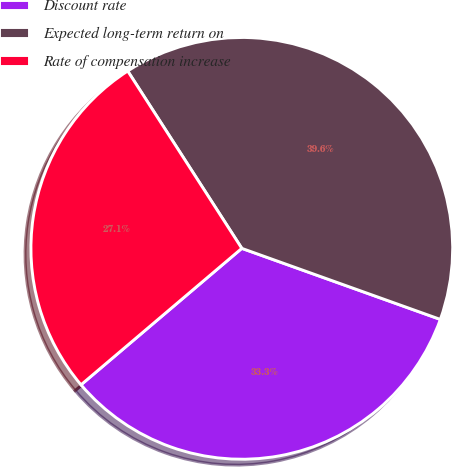Convert chart. <chart><loc_0><loc_0><loc_500><loc_500><pie_chart><fcel>Discount rate<fcel>Expected long-term return on<fcel>Rate of compensation increase<nl><fcel>33.33%<fcel>39.57%<fcel>27.1%<nl></chart> 